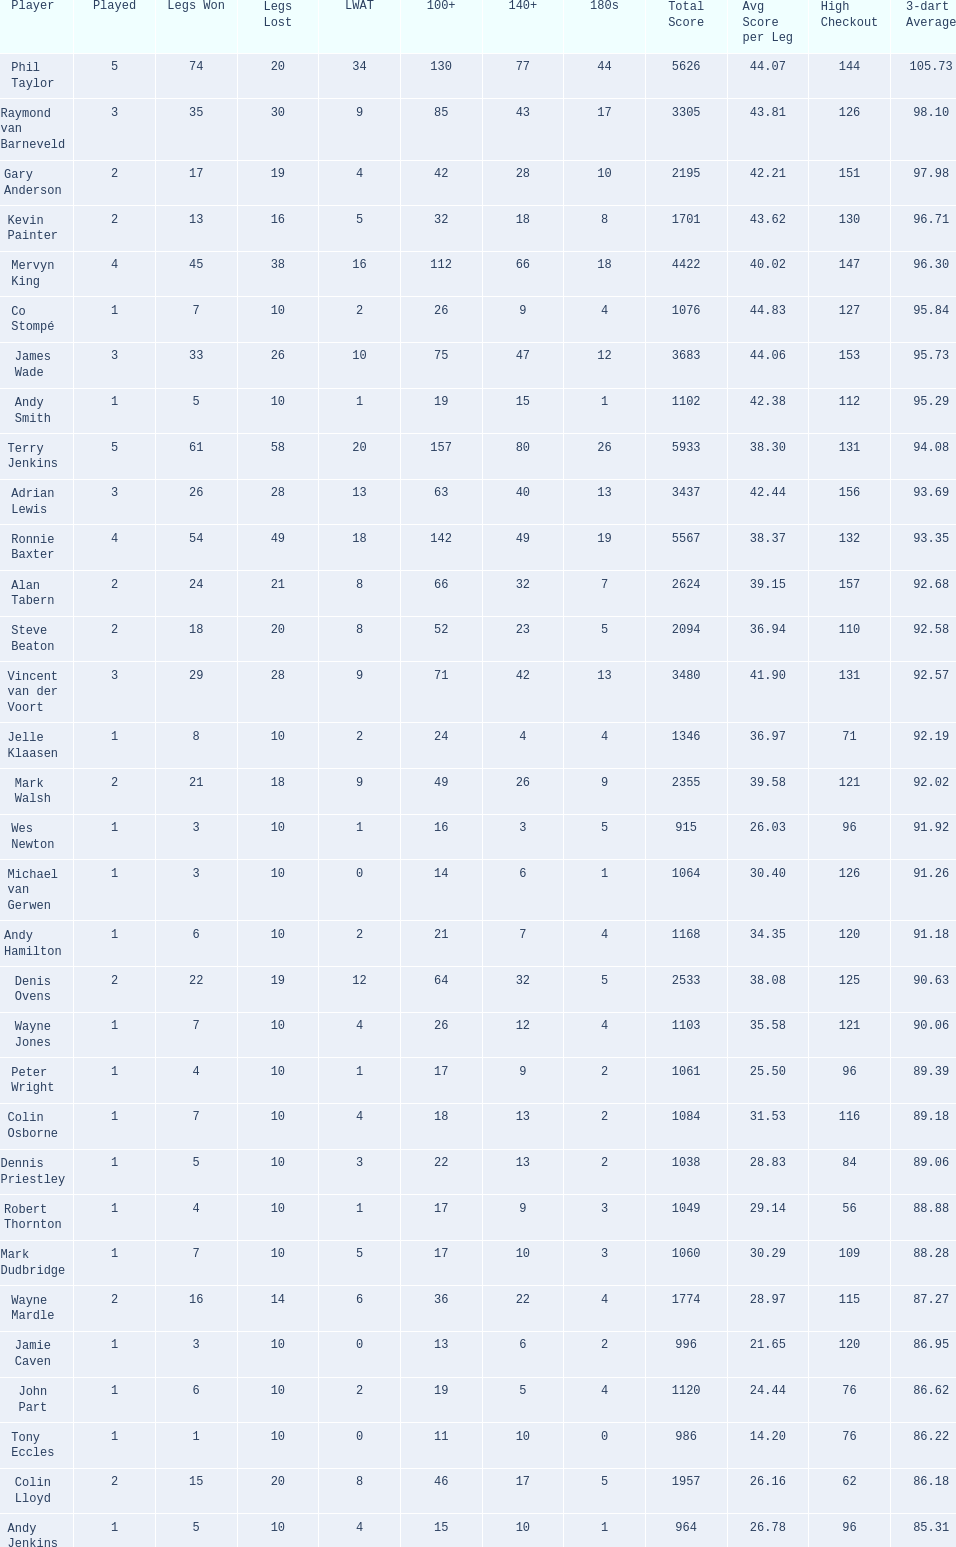What were the total number of legs won by ronnie baxter? 54. Could you parse the entire table? {'header': ['Player', 'Played', 'Legs Won', 'Legs Lost', 'LWAT', '100+', '140+', '180s', 'Total Score', 'Avg Score per Leg', 'High Checkout', '3-dart Average'], 'rows': [['Phil Taylor', '5', '74', '20', '34', '130', '77', '44', '5626', '44.07', '144', '105.73'], ['Raymond van Barneveld', '3', '35', '30', '9', '85', '43', '17', '3305', '43.81', '126', '98.10'], ['Gary Anderson', '2', '17', '19', '4', '42', '28', '10', '2195', '42.21', '151', '97.98'], ['Kevin Painter', '2', '13', '16', '5', '32', '18', '8', '1701', '43.62', '130', '96.71'], ['Mervyn King', '4', '45', '38', '16', '112', '66', '18', '4422', '40.02', '147', '96.30'], ['Co Stompé', '1', '7', '10', '2', '26', '9', '4', '1076', '44.83', '127', '95.84'], ['James Wade', '3', '33', '26', '10', '75', '47', '12', '3683', '44.06', '153', '95.73'], ['Andy Smith', '1', '5', '10', '1', '19', '15', '1', '1102', '42.38', '112', '95.29'], ['Terry Jenkins', '5', '61', '58', '20', '157', '80', '26', '5933', '38.30', '131', '94.08'], ['Adrian Lewis', '3', '26', '28', '13', '63', '40', '13', '3437', '42.44', '156', '93.69'], ['Ronnie Baxter', '4', '54', '49', '18', '142', '49', '19', '5567', '38.37', '132', '93.35'], ['Alan Tabern', '2', '24', '21', '8', '66', '32', '7', '2624', '39.15', '157', '92.68'], ['Steve Beaton', '2', '18', '20', '8', '52', '23', '5', '2094', '36.94', '110', '92.58'], ['Vincent van der Voort', '3', '29', '28', '9', '71', '42', '13', '3480', '41.90', '131', '92.57'], ['Jelle Klaasen', '1', '8', '10', '2', '24', '4', '4', '1346', '36.97', '71', '92.19'], ['Mark Walsh', '2', '21', '18', '9', '49', '26', '9', '2355', '39.58', '121', '92.02'], ['Wes Newton', '1', '3', '10', '1', '16', '3', '5', '915', '26.03', '96', '91.92'], ['Michael van Gerwen', '1', '3', '10', '0', '14', '6', '1', '1064', '30.40', '126', '91.26'], ['Andy Hamilton', '1', '6', '10', '2', '21', '7', '4', '1168', '34.35', '120', '91.18'], ['Denis Ovens', '2', '22', '19', '12', '64', '32', '5', '2533', '38.08', '125', '90.63'], ['Wayne Jones', '1', '7', '10', '4', '26', '12', '4', '1103', '35.58', '121', '90.06'], ['Peter Wright', '1', '4', '10', '1', '17', '9', '2', '1061', '25.50', '96', '89.39'], ['Colin Osborne', '1', '7', '10', '4', '18', '13', '2', '1084', '31.53', '116', '89.18'], ['Dennis Priestley', '1', '5', '10', '3', '22', '13', '2', '1038', '28.83', '84', '89.06'], ['Robert Thornton', '1', '4', '10', '1', '17', '9', '3', '1049', '29.14', '56', '88.88'], ['Mark Dudbridge', '1', '7', '10', '5', '17', '10', '3', '1060', '30.29', '109', '88.28'], ['Wayne Mardle', '2', '16', '14', '6', '36', '22', '4', '1774', '28.97', '115', '87.27'], ['Jamie Caven', '1', '3', '10', '0', '13', '6', '2', '996', '21.65', '120', '86.95'], ['John Part', '1', '6', '10', '2', '19', '5', '4', '1120', '24.44', '76', '86.62'], ['Tony Eccles', '1', '1', '10', '0', '11', '10', '0', '986', '14.20', '76', '86.22'], ['Colin Lloyd', '2', '15', '20', '8', '46', '17', '5', '1957', '26.16', '62', '86.18'], ['Andy Jenkins', '1', '5', '10', '4', '15', '10', '1', '964', '26.78', '96', '85.31']]} 